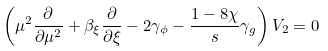Convert formula to latex. <formula><loc_0><loc_0><loc_500><loc_500>\left ( \mu ^ { 2 } \frac { \partial } { \partial \mu ^ { 2 } } + \beta _ { \xi } \frac { \partial } { \partial \xi } - 2 \gamma _ { \phi } - \frac { 1 - 8 \chi } { s } \gamma _ { g } \right ) V _ { 2 } = 0</formula> 